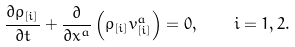Convert formula to latex. <formula><loc_0><loc_0><loc_500><loc_500>\frac { \partial \rho _ { [ i ] } } { \partial t } + \frac { \partial } { \partial x ^ { a } } \left ( \rho _ { [ i ] } v ^ { a } _ { [ i ] } \right ) = 0 , \quad i = 1 , 2 .</formula> 